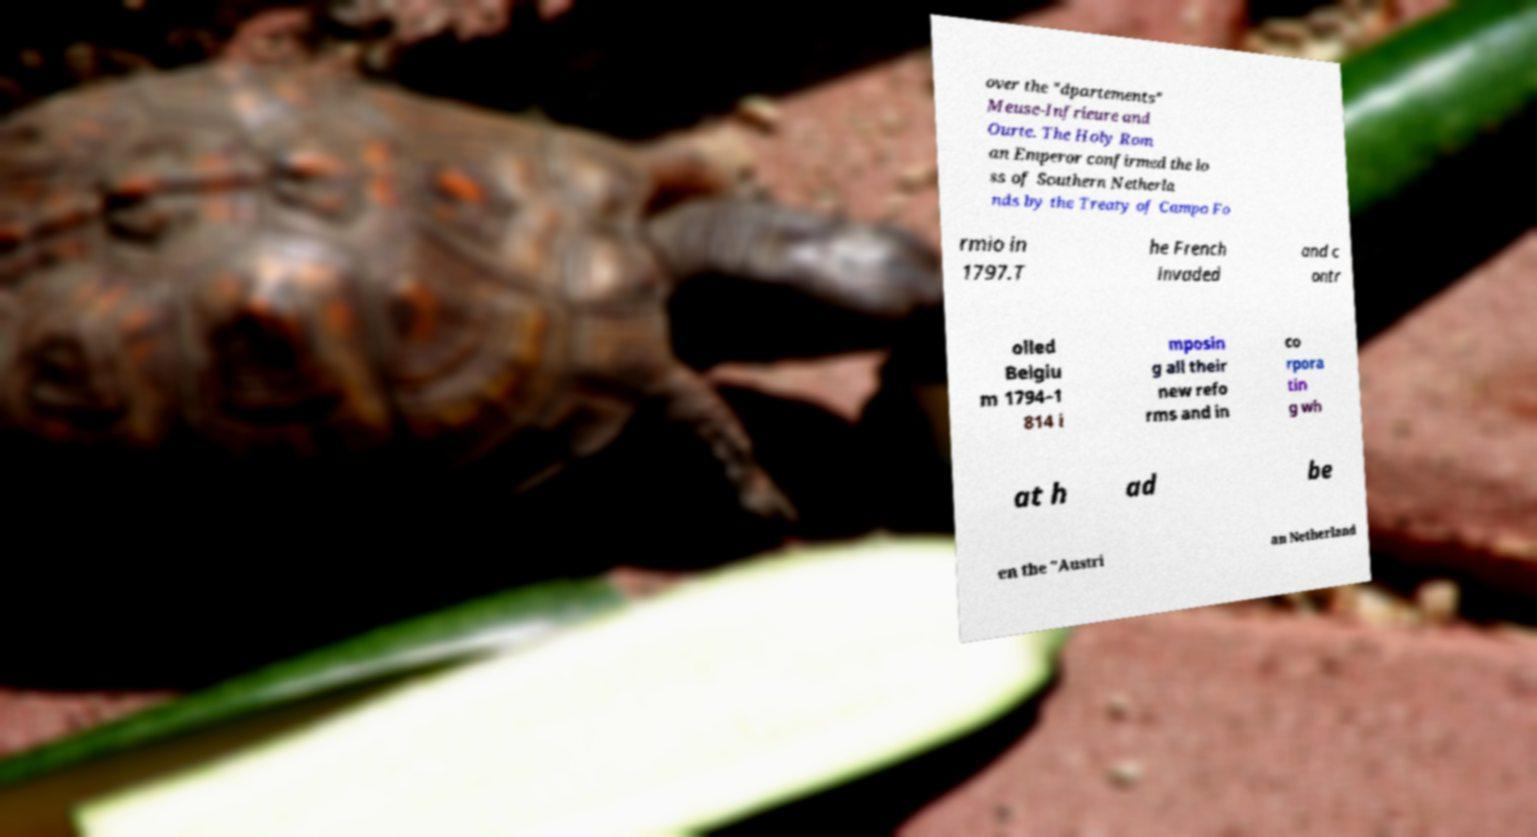There's text embedded in this image that I need extracted. Can you transcribe it verbatim? over the "dpartements" Meuse-Infrieure and Ourte. The Holy Rom an Emperor confirmed the lo ss of Southern Netherla nds by the Treaty of Campo Fo rmio in 1797.T he French invaded and c ontr olled Belgiu m 1794–1 814 i mposin g all their new refo rms and in co rpora tin g wh at h ad be en the "Austri an Netherland 